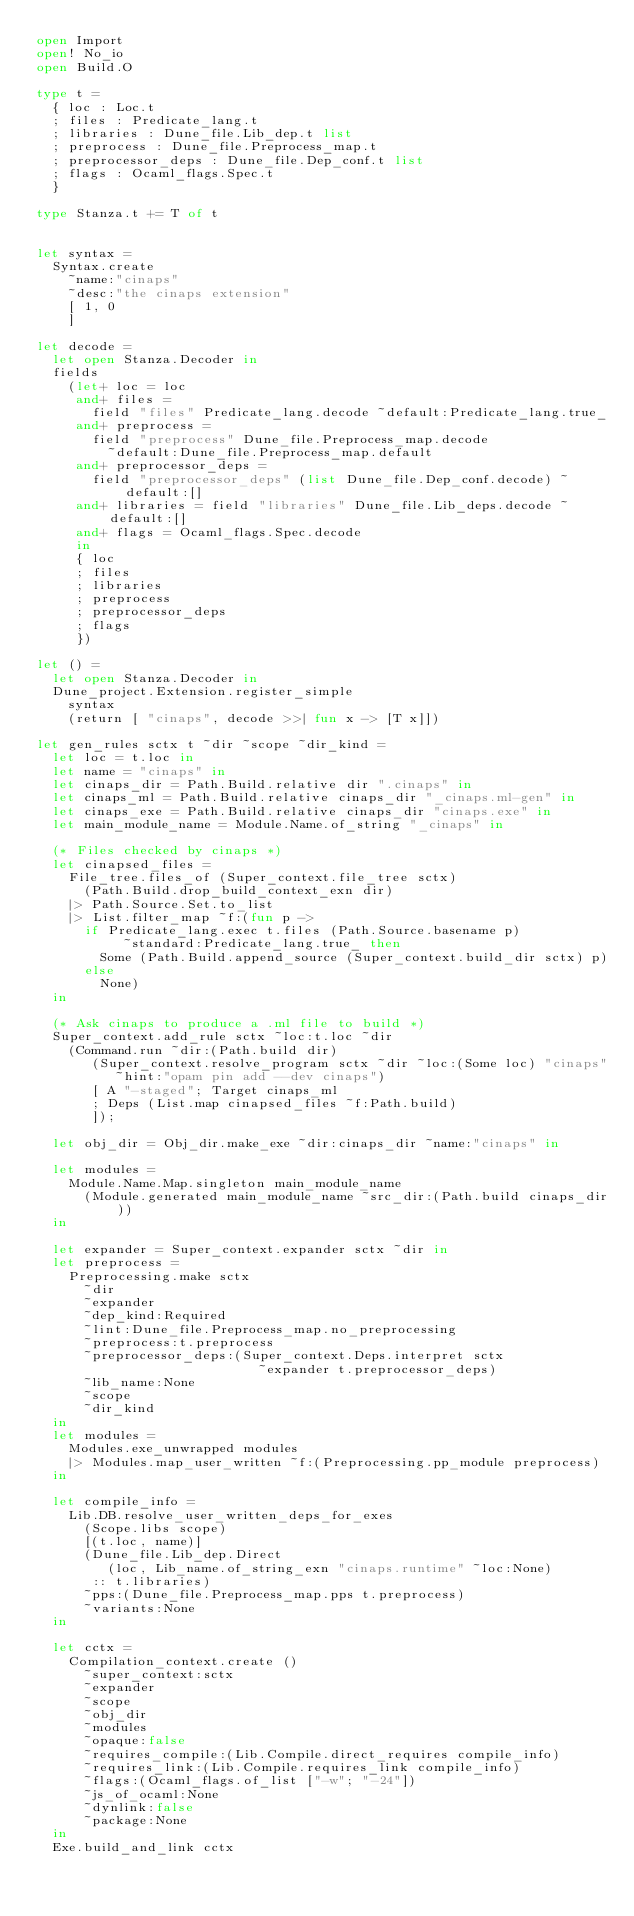<code> <loc_0><loc_0><loc_500><loc_500><_OCaml_>open Import
open! No_io
open Build.O

type t =
  { loc : Loc.t
  ; files : Predicate_lang.t
  ; libraries : Dune_file.Lib_dep.t list
  ; preprocess : Dune_file.Preprocess_map.t
  ; preprocessor_deps : Dune_file.Dep_conf.t list
  ; flags : Ocaml_flags.Spec.t
  }

type Stanza.t += T of t


let syntax =
  Syntax.create
    ~name:"cinaps"
    ~desc:"the cinaps extension"
    [ 1, 0
    ]

let decode =
  let open Stanza.Decoder in
  fields
    (let+ loc = loc
     and+ files =
       field "files" Predicate_lang.decode ~default:Predicate_lang.true_
     and+ preprocess =
       field "preprocess" Dune_file.Preprocess_map.decode
         ~default:Dune_file.Preprocess_map.default
     and+ preprocessor_deps =
       field "preprocessor_deps" (list Dune_file.Dep_conf.decode) ~default:[]
     and+ libraries = field "libraries" Dune_file.Lib_deps.decode ~default:[]
     and+ flags = Ocaml_flags.Spec.decode
     in
     { loc
     ; files
     ; libraries
     ; preprocess
     ; preprocessor_deps
     ; flags
     })

let () =
  let open Stanza.Decoder in
  Dune_project.Extension.register_simple
    syntax
    (return [ "cinaps", decode >>| fun x -> [T x]])

let gen_rules sctx t ~dir ~scope ~dir_kind =
  let loc = t.loc in
  let name = "cinaps" in
  let cinaps_dir = Path.Build.relative dir ".cinaps" in
  let cinaps_ml = Path.Build.relative cinaps_dir "_cinaps.ml-gen" in
  let cinaps_exe = Path.Build.relative cinaps_dir "cinaps.exe" in
  let main_module_name = Module.Name.of_string "_cinaps" in

  (* Files checked by cinaps *)
  let cinapsed_files =
    File_tree.files_of (Super_context.file_tree sctx)
      (Path.Build.drop_build_context_exn dir)
    |> Path.Source.Set.to_list
    |> List.filter_map ~f:(fun p ->
      if Predicate_lang.exec t.files (Path.Source.basename p)
           ~standard:Predicate_lang.true_ then
        Some (Path.Build.append_source (Super_context.build_dir sctx) p)
      else
        None)
  in

  (* Ask cinaps to produce a .ml file to build *)
  Super_context.add_rule sctx ~loc:t.loc ~dir
    (Command.run ~dir:(Path.build dir)
       (Super_context.resolve_program sctx ~dir ~loc:(Some loc) "cinaps"
          ~hint:"opam pin add --dev cinaps")
       [ A "-staged"; Target cinaps_ml
       ; Deps (List.map cinapsed_files ~f:Path.build)
       ]);

  let obj_dir = Obj_dir.make_exe ~dir:cinaps_dir ~name:"cinaps" in

  let modules =
    Module.Name.Map.singleton main_module_name
      (Module.generated main_module_name ~src_dir:(Path.build cinaps_dir))
  in

  let expander = Super_context.expander sctx ~dir in
  let preprocess =
    Preprocessing.make sctx
      ~dir
      ~expander
      ~dep_kind:Required
      ~lint:Dune_file.Preprocess_map.no_preprocessing
      ~preprocess:t.preprocess
      ~preprocessor_deps:(Super_context.Deps.interpret sctx
                            ~expander t.preprocessor_deps)
      ~lib_name:None
      ~scope
      ~dir_kind
  in
  let modules =
    Modules.exe_unwrapped modules
    |> Modules.map_user_written ~f:(Preprocessing.pp_module preprocess)
  in

  let compile_info =
    Lib.DB.resolve_user_written_deps_for_exes
      (Scope.libs scope)
      [(t.loc, name)]
      (Dune_file.Lib_dep.Direct
         (loc, Lib_name.of_string_exn "cinaps.runtime" ~loc:None)
       :: t.libraries)
      ~pps:(Dune_file.Preprocess_map.pps t.preprocess)
      ~variants:None
  in

  let cctx =
    Compilation_context.create ()
      ~super_context:sctx
      ~expander
      ~scope
      ~obj_dir
      ~modules
      ~opaque:false
      ~requires_compile:(Lib.Compile.direct_requires compile_info)
      ~requires_link:(Lib.Compile.requires_link compile_info)
      ~flags:(Ocaml_flags.of_list ["-w"; "-24"])
      ~js_of_ocaml:None
      ~dynlink:false
      ~package:None
  in
  Exe.build_and_link cctx</code> 